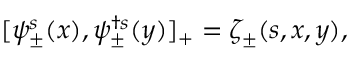Convert formula to latex. <formula><loc_0><loc_0><loc_500><loc_500>[ \psi _ { \pm } ^ { s } ( x ) , \psi _ { \pm } ^ { \dagger s } ( y ) ] _ { + } = \zeta _ { \pm } ( s , x , y ) ,</formula> 